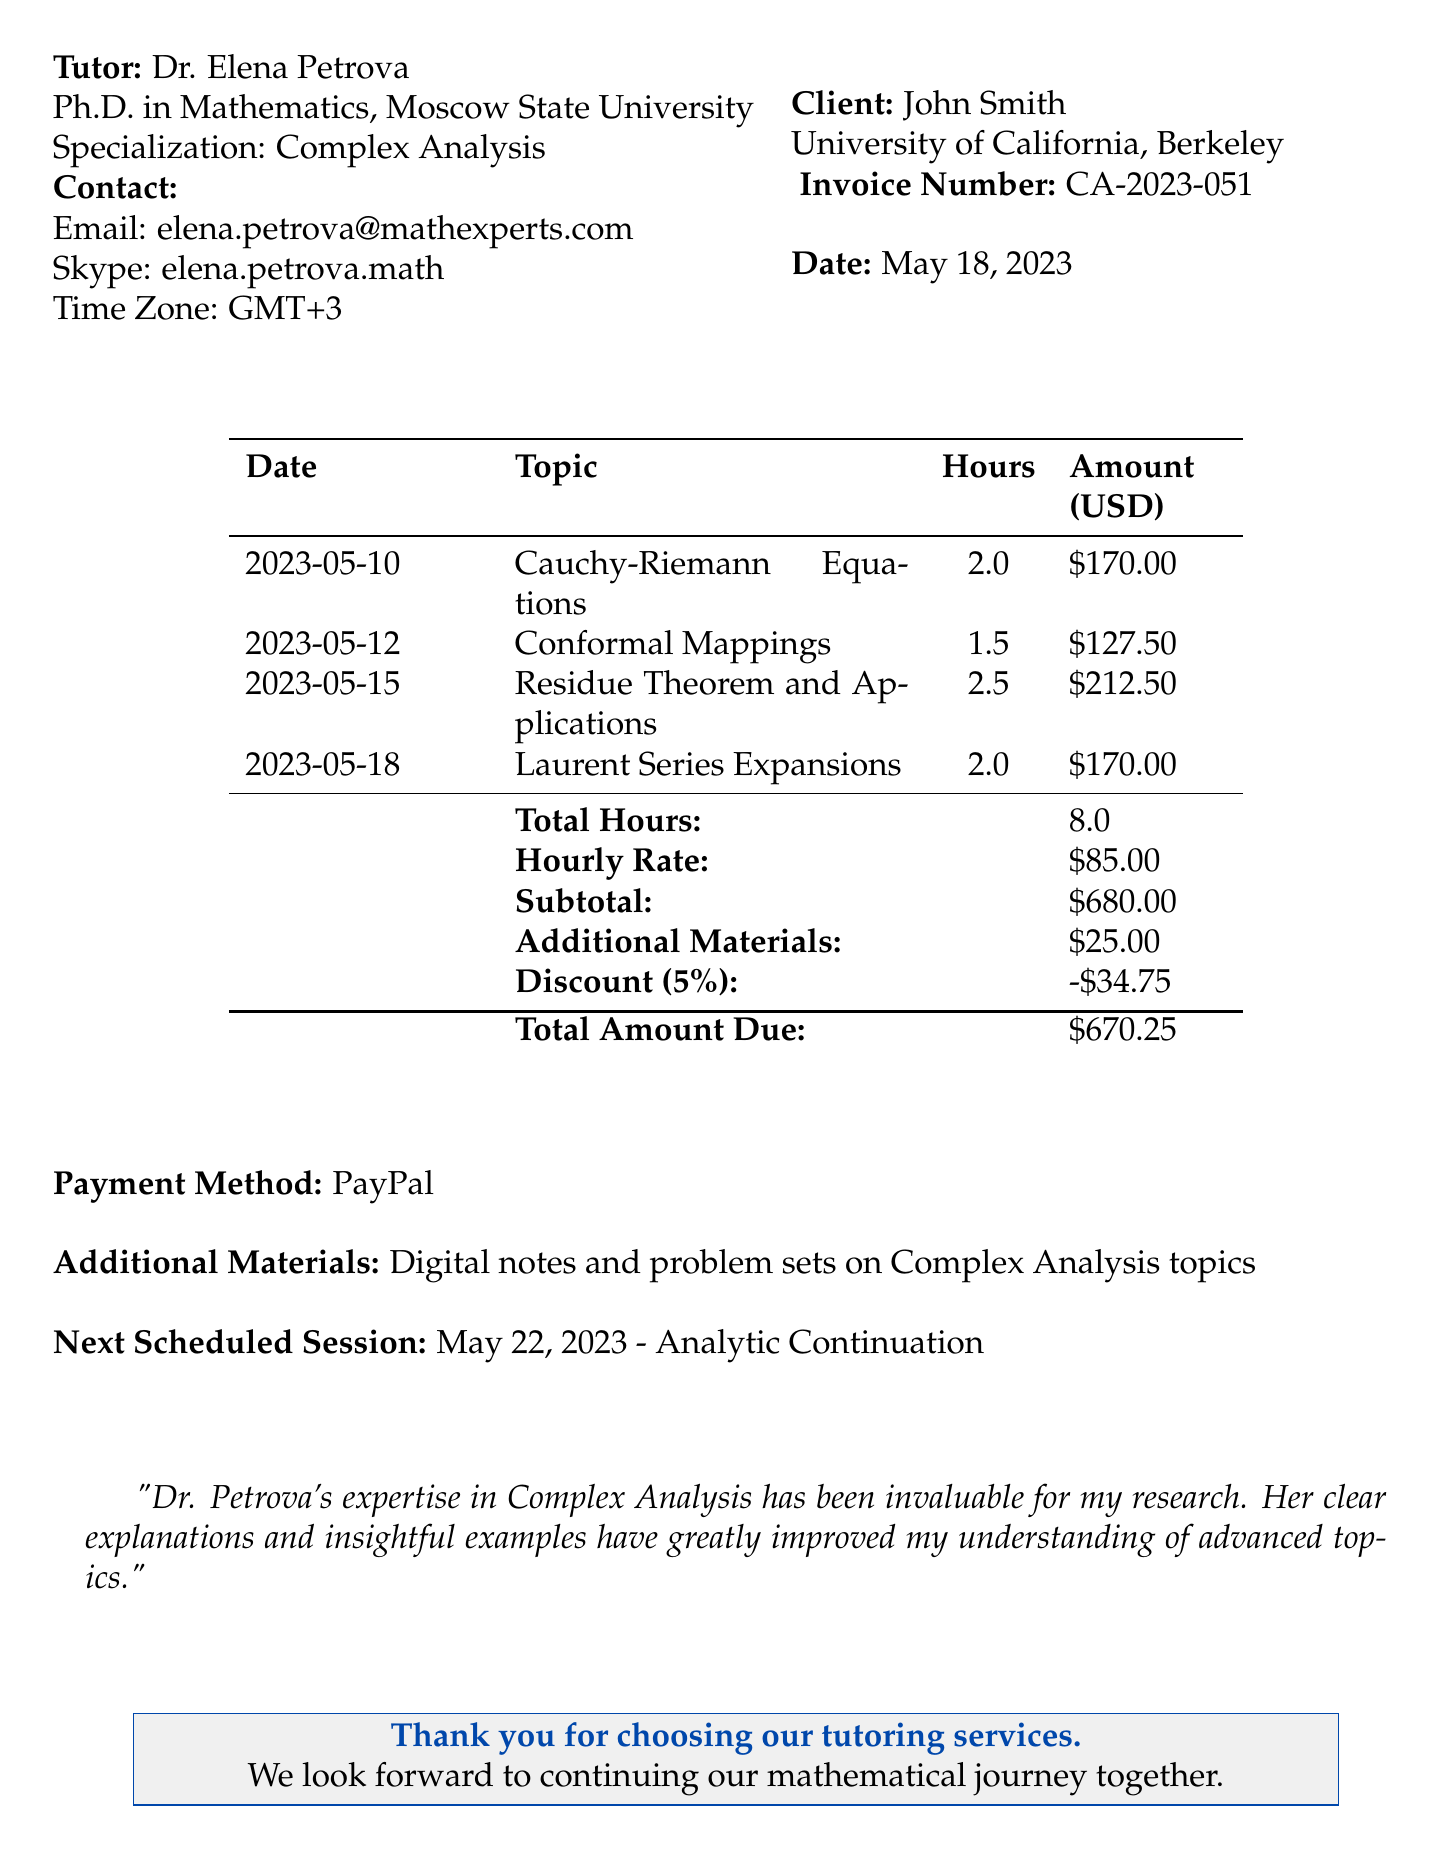What is the tutor's name? The tutor's name is explicitly mentioned in the document.
Answer: Dr. Elena Petrova What is the hourly rate for the tutoring sessions? The hourly rate is detailed in the financial section of the document.
Answer: 85 USD What is the total time spent on tutoring sessions? The total time is provided in the summary of hours worked throughout the sessions.
Answer: 8 hours What is the final amount due after the discount? The final amount is highlighted in the table summarizing the financial totals.
Answer: 670.25 USD What topic was covered in the session on May 12, 2023? The topics for each session are specified by date in the table.
Answer: Conformal Mappings What is the reason for the applied discount? The document states the reason provided for the discount.
Answer: Returning client How much was charged for additional materials? The cost for additional materials is stated in the itemized financial section.
Answer: 25 USD What was the date of the next scheduled session? The date for the upcoming session is explicitly mentioned in its own section.
Answer: May 22, 2023 What is the payment method used for the tutoring services? The payment method is mentioned in the financial summary of the document.
Answer: PayPal 